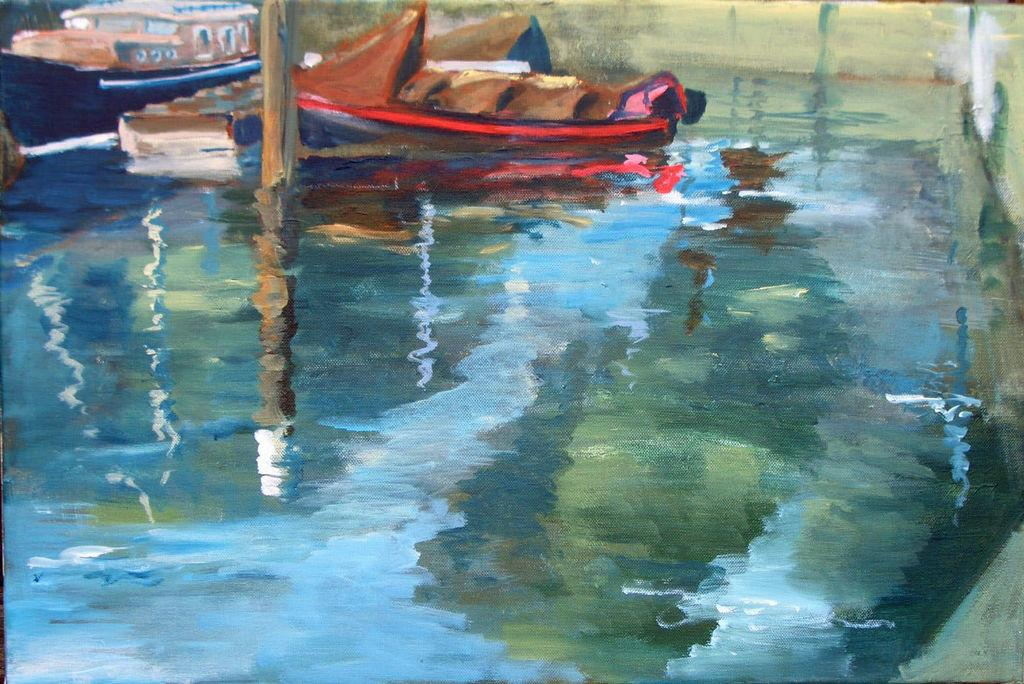What is the main subject of the image? The image contains a painting. What is depicted at the bottom of the painting? There is water depicted at the bottom of the painting. How many boats can be seen on the water in the painting? There are two boats visible on the water in the painting. What type of cakes are being served at the place depicted in the painting? There is no place or cakes depicted in the painting; it only shows water and two boats. 